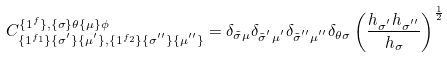<formula> <loc_0><loc_0><loc_500><loc_500>C ^ { \{ 1 ^ { f } \} , \{ \sigma \} \theta \{ \mu \} \phi } _ { \{ 1 ^ { f _ { 1 } } \} \{ \sigma ^ { ^ { \prime } } \} \{ \mu ^ { ^ { \prime } } \} , \{ 1 ^ { f _ { 2 } } \} \{ \sigma ^ { ^ { \prime \prime } } \} \{ \mu ^ { ^ { \prime \prime } } \} } = \delta _ { \tilde { \sigma } \mu } \delta _ { \tilde { \sigma } ^ { ^ { \prime } } \mu ^ { ^ { \prime } } } \delta _ { \tilde { \sigma } ^ { ^ { \prime \prime } } \mu ^ { ^ { \prime \prime } } } \delta _ { \theta \sigma } \left ( \frac { h _ { \sigma ^ { ^ { \prime } } } h _ { \sigma ^ { ^ { \prime \prime } } } } { h _ { \sigma } } \right ) ^ { \frac { 1 } { 2 } }</formula> 